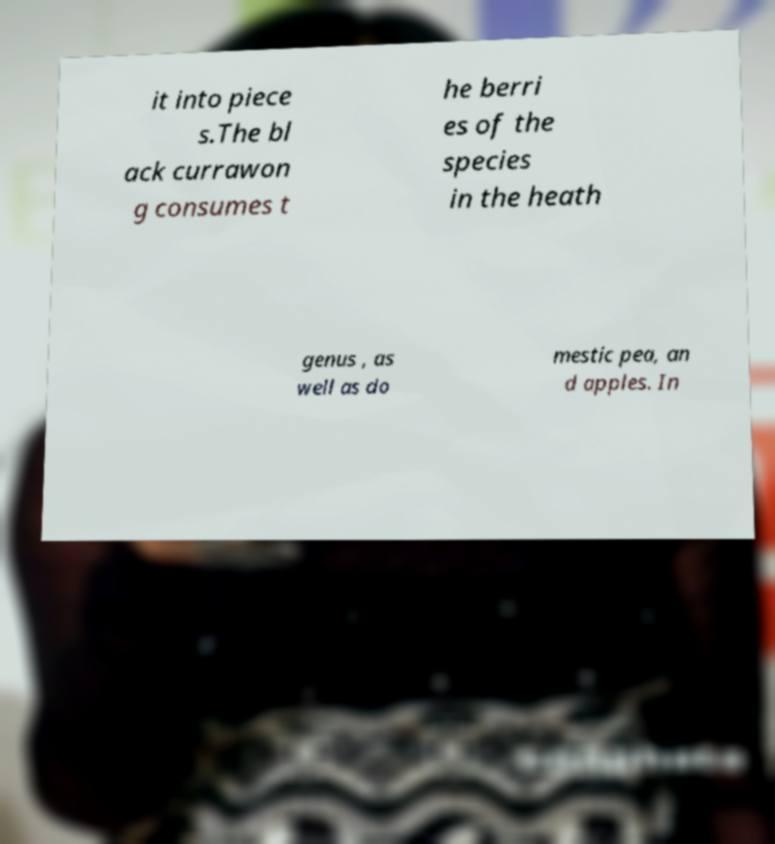I need the written content from this picture converted into text. Can you do that? it into piece s.The bl ack currawon g consumes t he berri es of the species in the heath genus , as well as do mestic pea, an d apples. In 